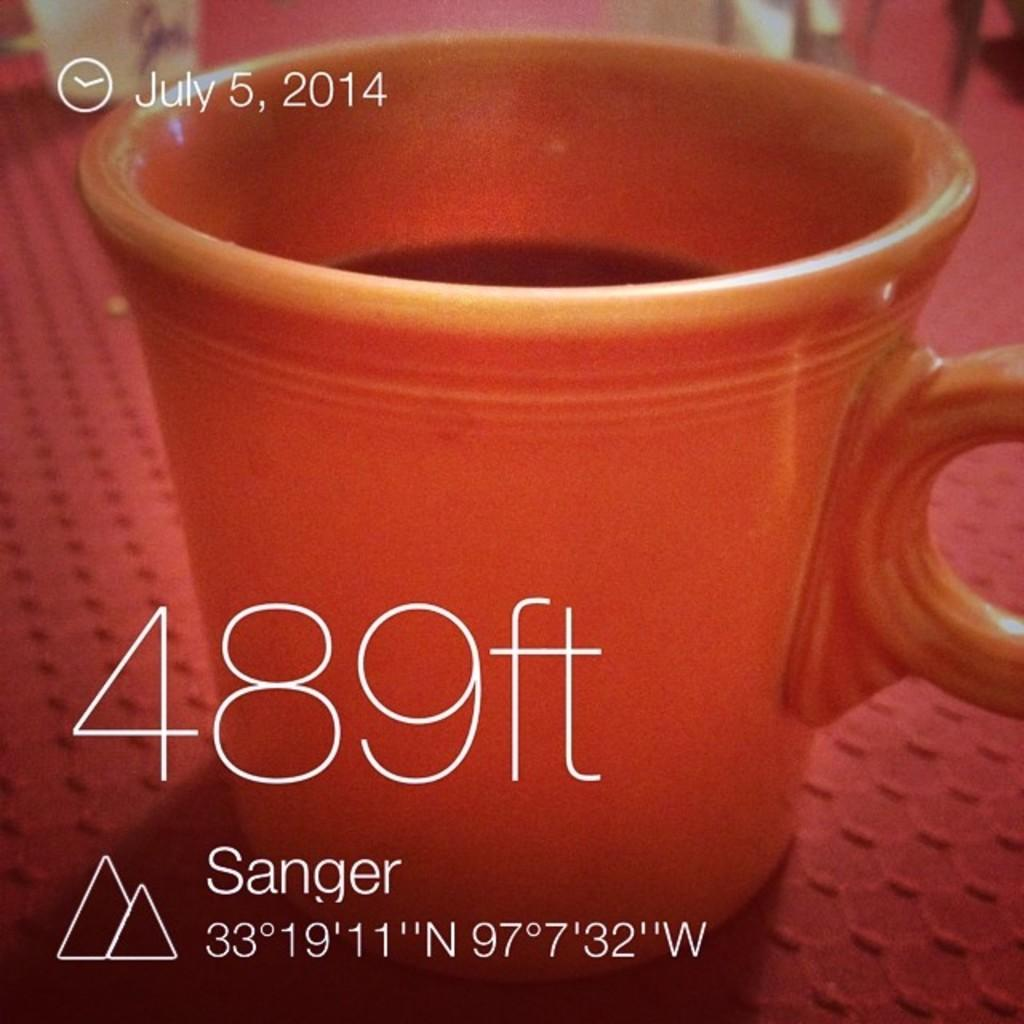<image>
Describe the image concisely. an orange mug on a table sits behind the numbers 489ft 